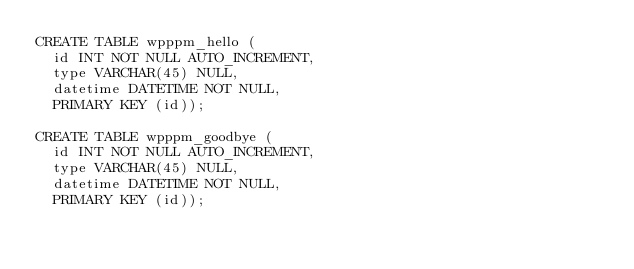Convert code to text. <code><loc_0><loc_0><loc_500><loc_500><_SQL_>CREATE TABLE wpppm_hello (
  id INT NOT NULL AUTO_INCREMENT,
  type VARCHAR(45) NULL,
  datetime DATETIME NOT NULL,
  PRIMARY KEY (id));

CREATE TABLE wpppm_goodbye (
  id INT NOT NULL AUTO_INCREMENT,
  type VARCHAR(45) NULL,
  datetime DATETIME NOT NULL,
  PRIMARY KEY (id));</code> 